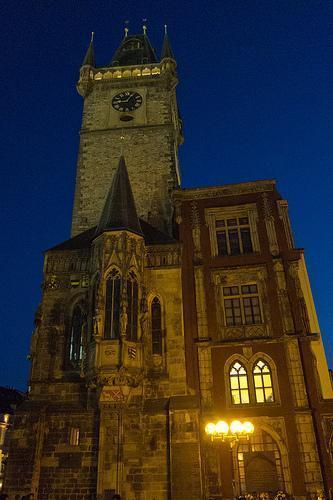How many big windows are lit up?
Give a very brief answer. 2. 